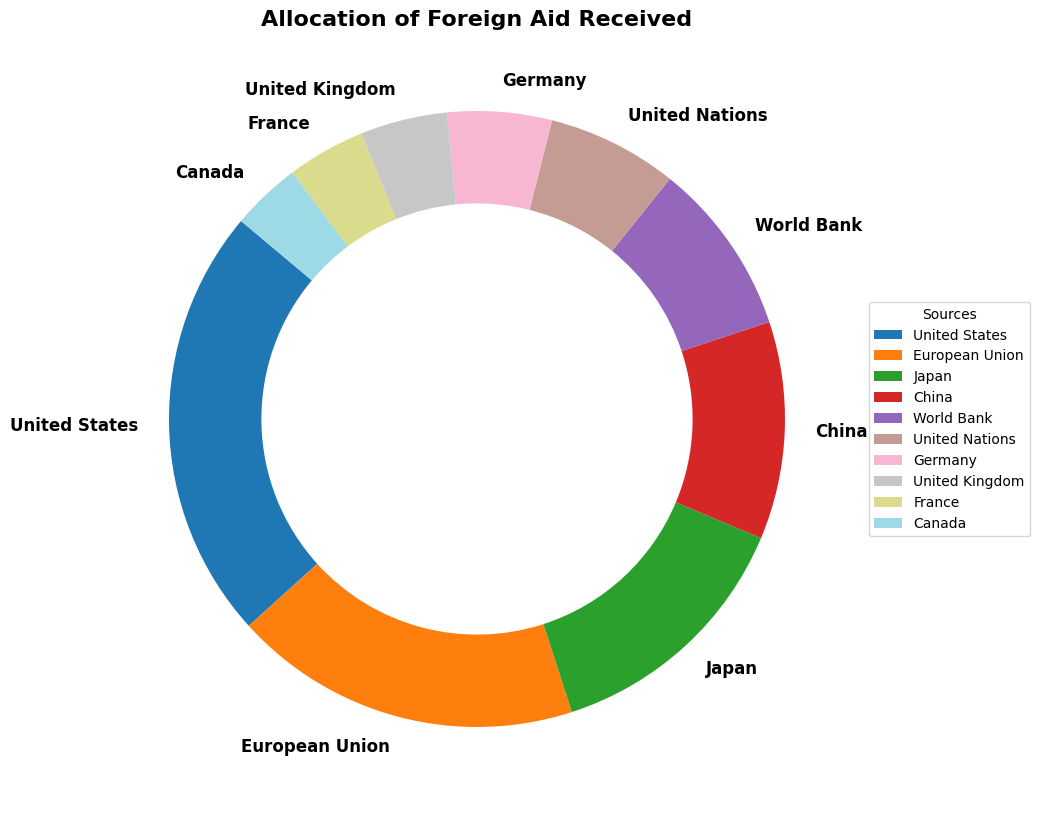Which source provided the highest amount of foreign aid? By looking at the ring chart, identify the segment that has the largest wedge and its corresponding label. The largest wedge belongs to the United States, indicating that it provided the highest amount of foreign aid.
Answer: United States What is the percentage of foreign aid provided by the European Union? Find the wedge labeled European Union and look at the percentage value displayed. It is 26.7%.
Answer: 26.7% How much more aid did Japan provide compared to China? Find the wedges labeled Japan and China and note their amounts as 300 million and 250 million respectively. Subtract the amount associated with China from Japan's amount: 300 - 250 = 50 million.
Answer: 50 million Which source contributed the least amount of foreign aid? Locate the smallest wedge in the ring chart and read its corresponding label. The smallest wedge is for Canada, indicating it contributed the least foreign aid.
Answer: Canada Which two sources combined provide a total of 290 million in foreign aid? Look for wedges with amounts that sum up to 290 million. Germany contributed 120 million and France contributed 90 million. Together, they total 290 million.
Answer: Germany and France What is the combined percentage share of the foreign aid from the World Bank and the United Nations? Identify the percentages for the World Bank (13.3%) and the United Nations (10%). Add these percentages: 13.3% + 10% = 23.3%.
Answer: 23.3% Compare the aid amounts from the United Kingdom and Canada. How much more did the UK receive? Find the wedges labeled United Kingdom and Canada. The UK received 100 million, while Canada received 80 million. Subtract Canada's amount from the UK's: 100 - 80 = 20 million.
Answer: 20 million What are the second and third highest sources of foreign aid after the United States? Identify the wedges with the highest amounts after the US wedge. The second highest is the European Union with 400 million, followed by Japan with 300 million.
Answer: European Union and Japan Is the aid from China closer to that from Japan or the World Bank? Observe the amounts for China (250 million), Japan (300 million), and the World Bank (200 million). Calculate the differences: 300 - 250 = 50 (Japan), 250 - 200 = 50 (World Bank). The differences are equal, thus it's equally close to both.
Answer: Equally close 